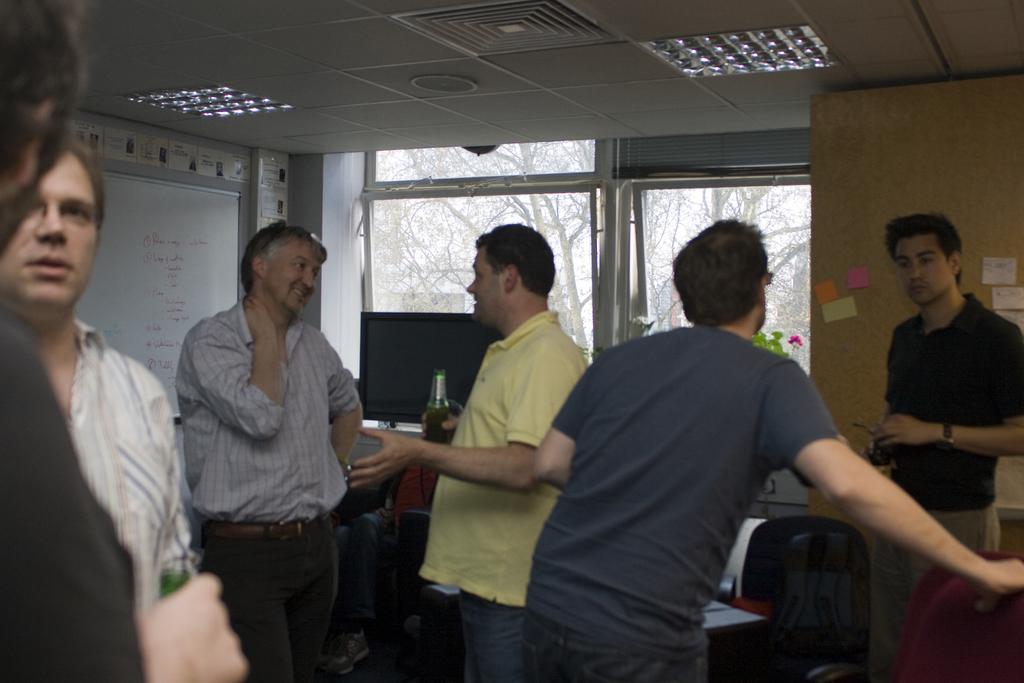How would you summarize this image in a sentence or two? As we can see in the image there is a wall, windows, white color board, lights, few people here and there, chairs and a table. On table there is a screen. The man standing in the middle is holding a bottle. Outside the window there are trees. 